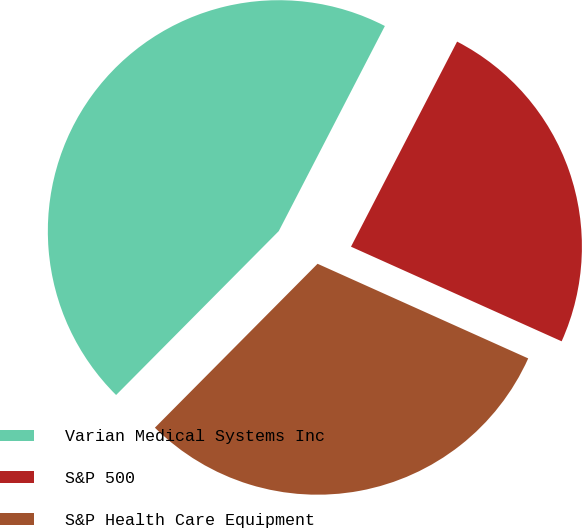Convert chart to OTSL. <chart><loc_0><loc_0><loc_500><loc_500><pie_chart><fcel>Varian Medical Systems Inc<fcel>S&P 500<fcel>S&P Health Care Equipment<nl><fcel>45.16%<fcel>24.12%<fcel>30.72%<nl></chart> 